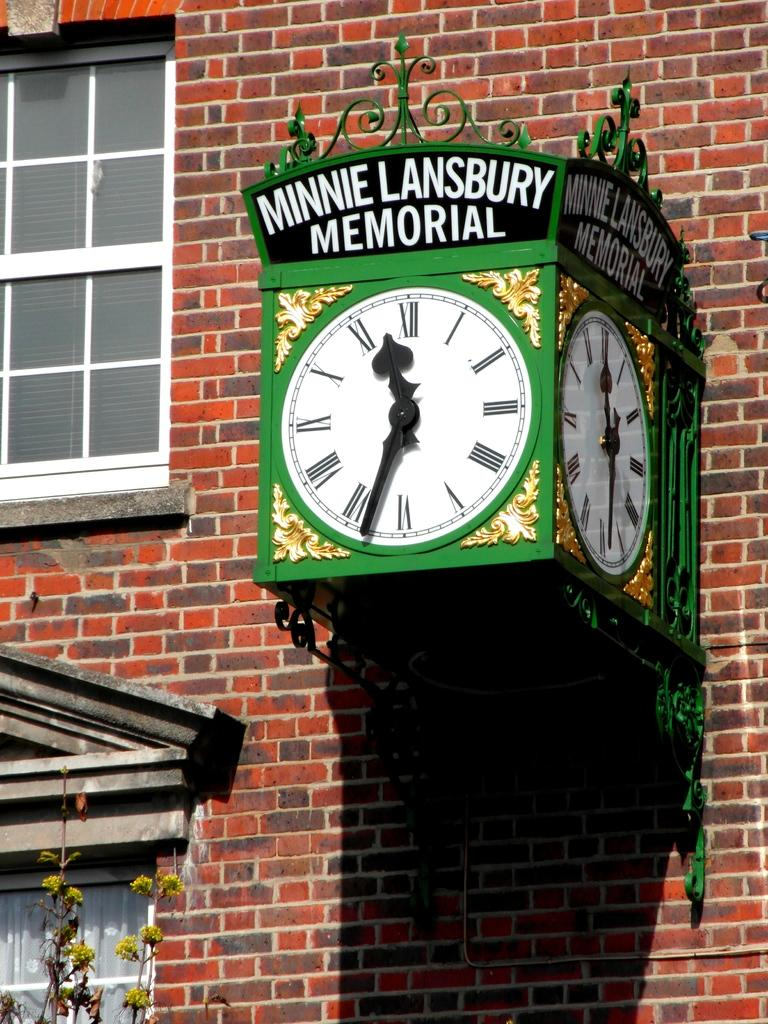<image>
Create a compact narrative representing the image presented. An old antique green clock tower from Minnie Lansbury Memorial 